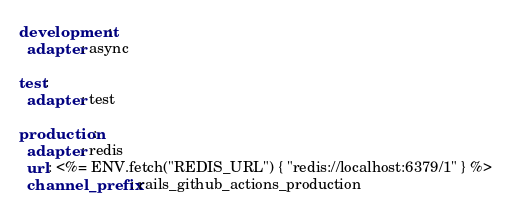<code> <loc_0><loc_0><loc_500><loc_500><_YAML_>development:
  adapter: async

test:
  adapter: test

production:
  adapter: redis
  url: <%= ENV.fetch("REDIS_URL") { "redis://localhost:6379/1" } %>
  channel_prefix: rails_github_actions_production
</code> 